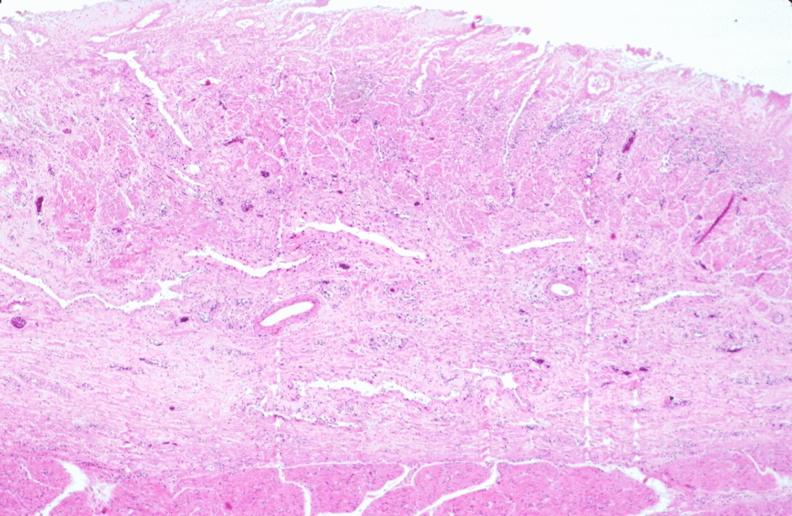s gastrointestinal present?
Answer the question using a single word or phrase. Yes 